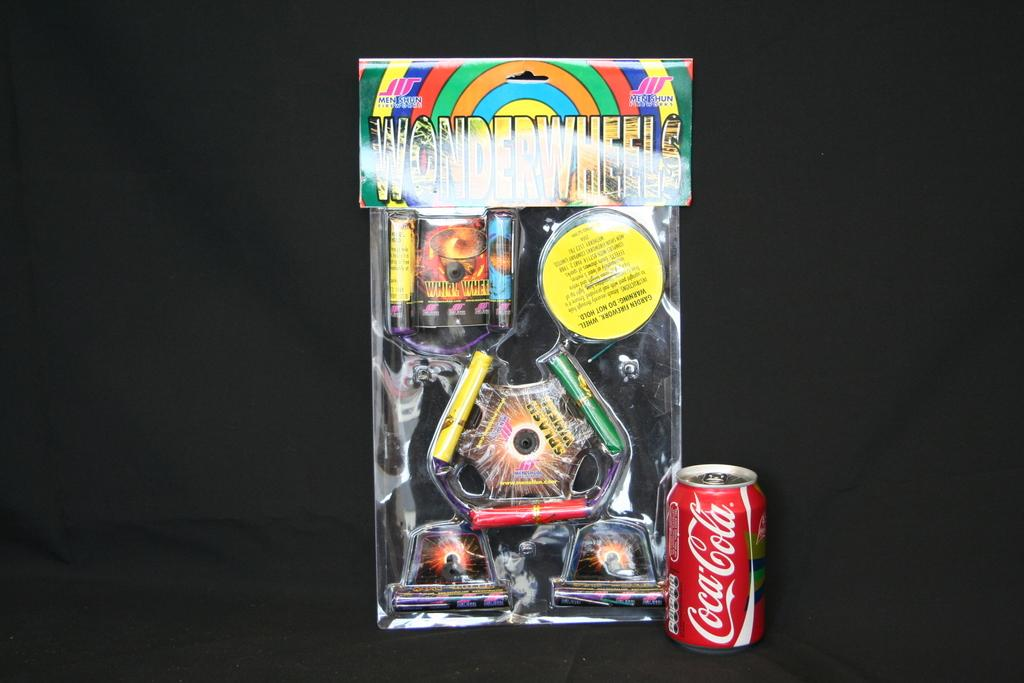What object is located on the right side of the image? There is a coke tin on the right side of the image. What can be found in the middle of the image? There is a toy box in the middle of the image. What color is the background of the image? The background of the image appears to be black. How does the coke tin crush the toy box in the image? The coke tin does not crush the toy box in the image; they are separate objects. What type of transportation is depicted in the image? There is no transportation depicted in the image. 